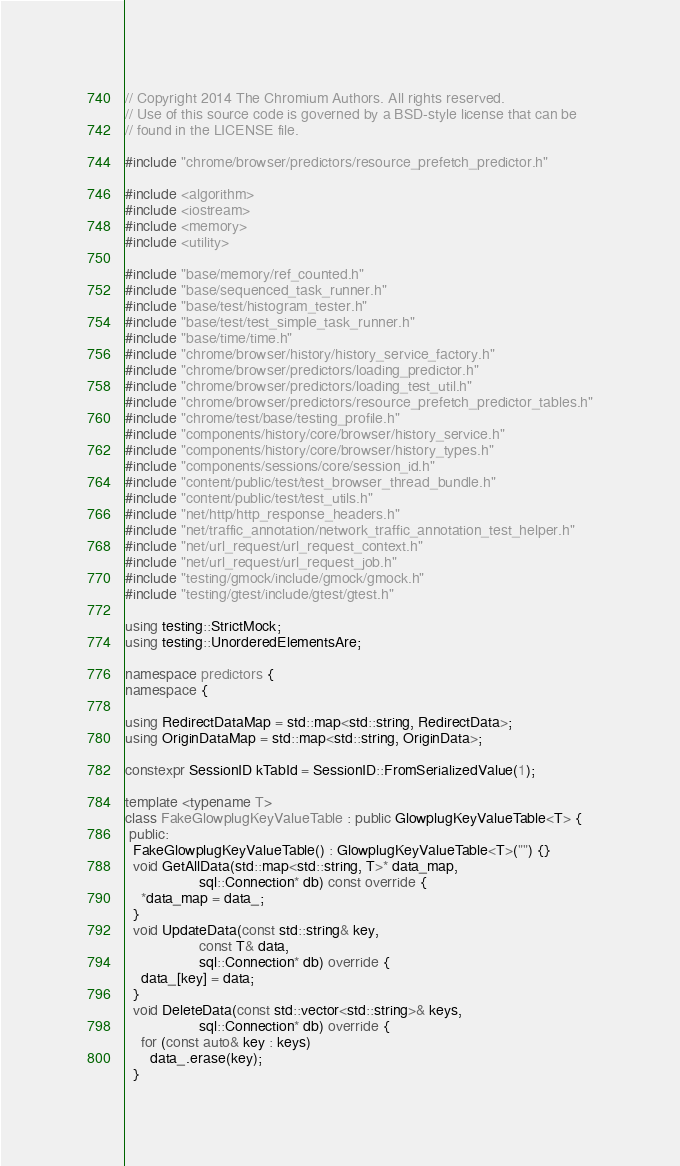<code> <loc_0><loc_0><loc_500><loc_500><_C++_>// Copyright 2014 The Chromium Authors. All rights reserved.
// Use of this source code is governed by a BSD-style license that can be
// found in the LICENSE file.

#include "chrome/browser/predictors/resource_prefetch_predictor.h"

#include <algorithm>
#include <iostream>
#include <memory>
#include <utility>

#include "base/memory/ref_counted.h"
#include "base/sequenced_task_runner.h"
#include "base/test/histogram_tester.h"
#include "base/test/test_simple_task_runner.h"
#include "base/time/time.h"
#include "chrome/browser/history/history_service_factory.h"
#include "chrome/browser/predictors/loading_predictor.h"
#include "chrome/browser/predictors/loading_test_util.h"
#include "chrome/browser/predictors/resource_prefetch_predictor_tables.h"
#include "chrome/test/base/testing_profile.h"
#include "components/history/core/browser/history_service.h"
#include "components/history/core/browser/history_types.h"
#include "components/sessions/core/session_id.h"
#include "content/public/test/test_browser_thread_bundle.h"
#include "content/public/test/test_utils.h"
#include "net/http/http_response_headers.h"
#include "net/traffic_annotation/network_traffic_annotation_test_helper.h"
#include "net/url_request/url_request_context.h"
#include "net/url_request/url_request_job.h"
#include "testing/gmock/include/gmock/gmock.h"
#include "testing/gtest/include/gtest/gtest.h"

using testing::StrictMock;
using testing::UnorderedElementsAre;

namespace predictors {
namespace {

using RedirectDataMap = std::map<std::string, RedirectData>;
using OriginDataMap = std::map<std::string, OriginData>;

constexpr SessionID kTabId = SessionID::FromSerializedValue(1);

template <typename T>
class FakeGlowplugKeyValueTable : public GlowplugKeyValueTable<T> {
 public:
  FakeGlowplugKeyValueTable() : GlowplugKeyValueTable<T>("") {}
  void GetAllData(std::map<std::string, T>* data_map,
                  sql::Connection* db) const override {
    *data_map = data_;
  }
  void UpdateData(const std::string& key,
                  const T& data,
                  sql::Connection* db) override {
    data_[key] = data;
  }
  void DeleteData(const std::vector<std::string>& keys,
                  sql::Connection* db) override {
    for (const auto& key : keys)
      data_.erase(key);
  }</code> 